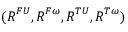<formula> <loc_0><loc_0><loc_500><loc_500>( R ^ { F U } , R ^ { F \omega } , R ^ { T U } , R ^ { T \omega } )</formula> 